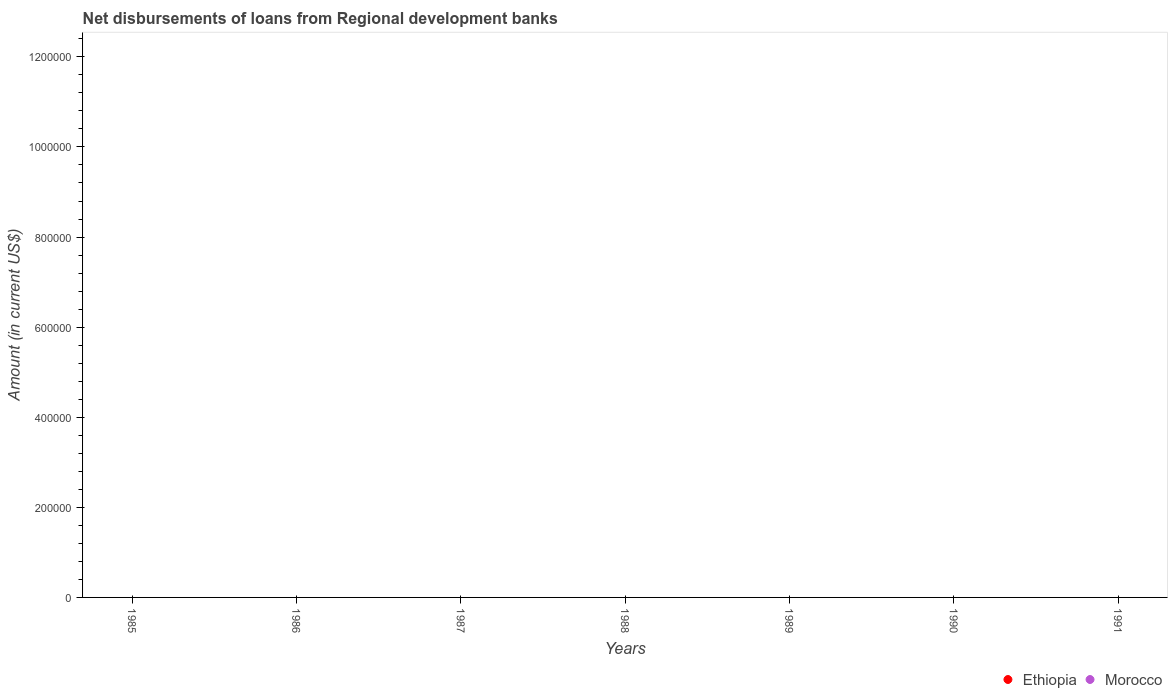How many different coloured dotlines are there?
Make the answer very short. 0. Is the number of dotlines equal to the number of legend labels?
Your answer should be compact. No. What is the amount of disbursements of loans from regional development banks in Morocco in 1986?
Make the answer very short. 0. Across all years, what is the minimum amount of disbursements of loans from regional development banks in Ethiopia?
Your answer should be compact. 0. What is the average amount of disbursements of loans from regional development banks in Morocco per year?
Keep it short and to the point. 0. In how many years, is the amount of disbursements of loans from regional development banks in Ethiopia greater than the average amount of disbursements of loans from regional development banks in Ethiopia taken over all years?
Your answer should be compact. 0. Is the amount of disbursements of loans from regional development banks in Morocco strictly less than the amount of disbursements of loans from regional development banks in Ethiopia over the years?
Keep it short and to the point. Yes. How many dotlines are there?
Keep it short and to the point. 0. What is the difference between two consecutive major ticks on the Y-axis?
Your answer should be very brief. 2.00e+05. Are the values on the major ticks of Y-axis written in scientific E-notation?
Your response must be concise. No. Does the graph contain grids?
Provide a succinct answer. No. How are the legend labels stacked?
Ensure brevity in your answer.  Horizontal. What is the title of the graph?
Your response must be concise. Net disbursements of loans from Regional development banks. What is the Amount (in current US$) of Morocco in 1985?
Your response must be concise. 0. What is the Amount (in current US$) of Ethiopia in 1986?
Provide a short and direct response. 0. What is the Amount (in current US$) of Morocco in 1987?
Make the answer very short. 0. What is the Amount (in current US$) in Morocco in 1988?
Make the answer very short. 0. What is the Amount (in current US$) in Morocco in 1990?
Offer a very short reply. 0. What is the total Amount (in current US$) of Morocco in the graph?
Your response must be concise. 0. What is the average Amount (in current US$) of Morocco per year?
Offer a very short reply. 0. 